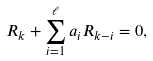<formula> <loc_0><loc_0><loc_500><loc_500>R _ { k } + \sum _ { i = 1 } ^ { \ell } a _ { i } R _ { k - i } = 0 ,</formula> 